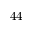<formula> <loc_0><loc_0><loc_500><loc_500>4 4</formula> 